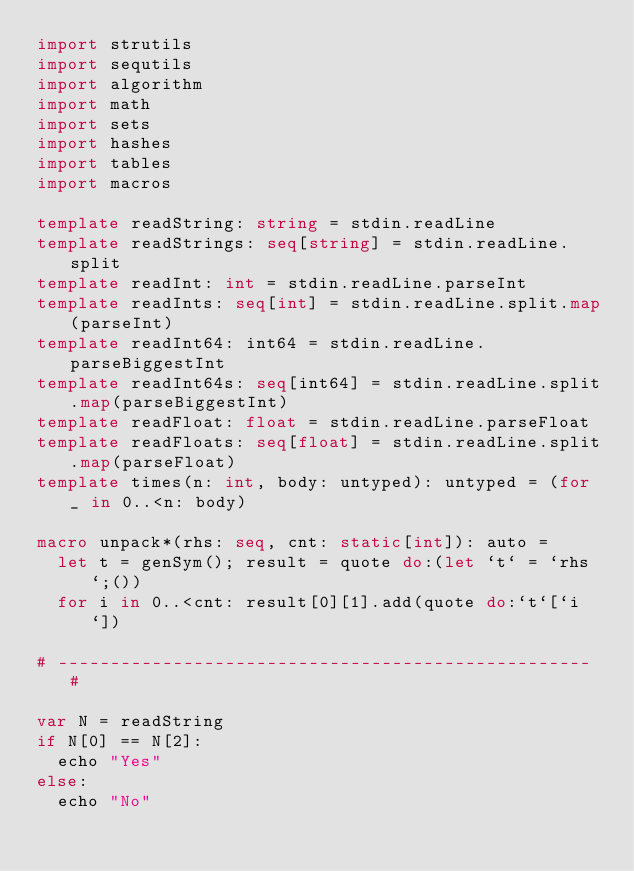<code> <loc_0><loc_0><loc_500><loc_500><_Nim_>import strutils
import sequtils
import algorithm
import math
import sets
import hashes
import tables
import macros

template readString: string = stdin.readLine
template readStrings: seq[string] = stdin.readLine.split
template readInt: int = stdin.readLine.parseInt
template readInts: seq[int] = stdin.readLine.split.map(parseInt)
template readInt64: int64 = stdin.readLine.parseBiggestInt
template readInt64s: seq[int64] = stdin.readLine.split.map(parseBiggestInt)
template readFloat: float = stdin.readLine.parseFloat
template readFloats: seq[float] = stdin.readLine.split.map(parseFloat)
template times(n: int, body: untyped): untyped = (for _ in 0..<n: body)

macro unpack*(rhs: seq, cnt: static[int]): auto =
  let t = genSym(); result = quote do:(let `t` = `rhs`;())
  for i in 0..<cnt: result[0][1].add(quote do:`t`[`i`])

# --------------------------------------------------- #

var N = readString
if N[0] == N[2]:
  echo "Yes"
else:
  echo "No"</code> 